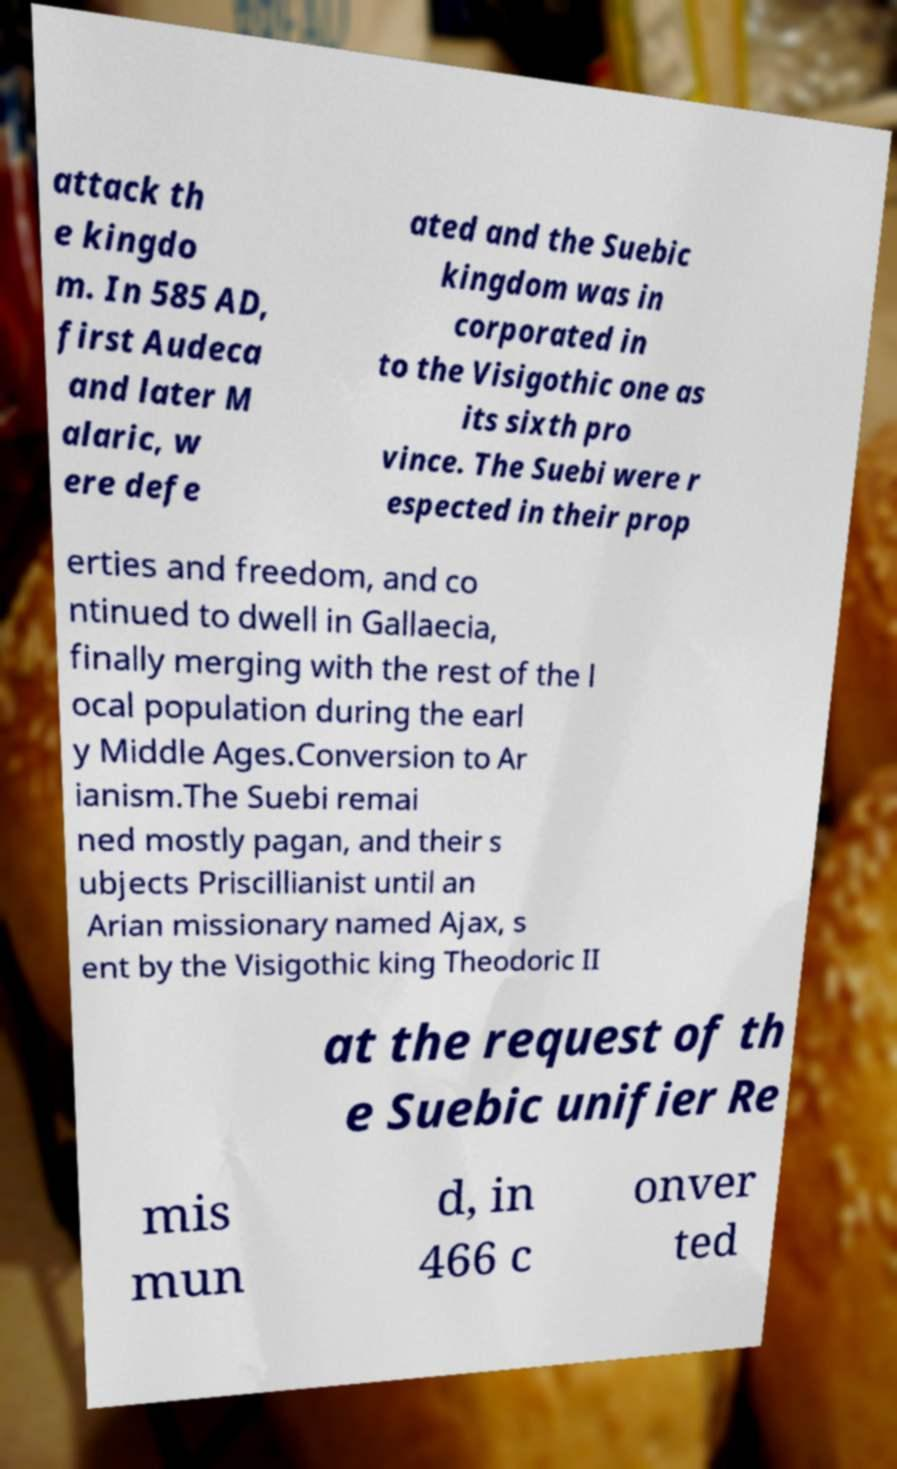Could you extract and type out the text from this image? attack th e kingdo m. In 585 AD, first Audeca and later M alaric, w ere defe ated and the Suebic kingdom was in corporated in to the Visigothic one as its sixth pro vince. The Suebi were r espected in their prop erties and freedom, and co ntinued to dwell in Gallaecia, finally merging with the rest of the l ocal population during the earl y Middle Ages.Conversion to Ar ianism.The Suebi remai ned mostly pagan, and their s ubjects Priscillianist until an Arian missionary named Ajax, s ent by the Visigothic king Theodoric II at the request of th e Suebic unifier Re mis mun d, in 466 c onver ted 